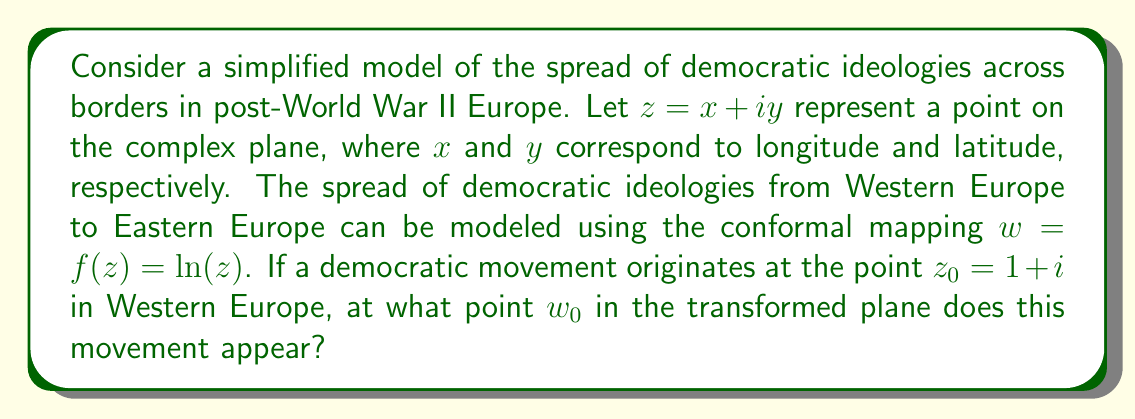Teach me how to tackle this problem. To solve this problem, we need to apply the given conformal mapping $f(z) = \ln(z)$ to the point $z_0 = 1 + i$. The natural logarithm of a complex number can be expressed in terms of its modulus and argument:

$$\ln(z) = \ln|z| + i\arg(z)$$

For $z_0 = 1 + i$:

1) First, calculate the modulus:
   $$|z_0| = \sqrt{1^2 + 1^2} = \sqrt{2}$$

2) Then, calculate the argument:
   $$\arg(z_0) = \tan^{-1}\left(\frac{1}{1}\right) = \frac{\pi}{4}$$

3) Now, apply the conformal mapping:
   $$w_0 = f(z_0) = \ln(z_0) = \ln|z_0| + i\arg(z_0)$$
   $$w_0 = \ln(\sqrt{2}) + i\frac{\pi}{4}$$

4) Simplify:
   $$w_0 = \frac{1}{2}\ln(2) + i\frac{\pi}{4}$$

This point $w_0$ in the transformed plane represents where the democratic movement originating from $z_0 = 1 + i$ in Western Europe appears in the new coordinate system after applying the conformal mapping.
Answer: $w_0 = \frac{1}{2}\ln(2) + i\frac{\pi}{4}$ 